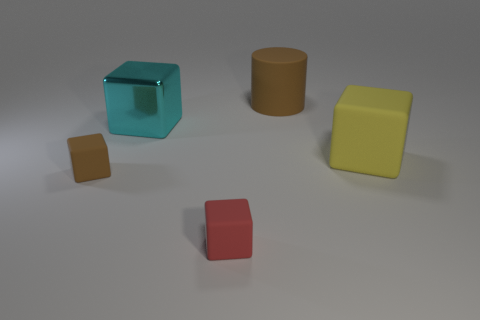Subtract all brown blocks. How many blocks are left? 3 Subtract 1 cylinders. How many cylinders are left? 0 Subtract all cubes. How many objects are left? 1 Subtract all brown cylinders. How many brown cubes are left? 1 Subtract all small red things. Subtract all red blocks. How many objects are left? 3 Add 1 tiny brown blocks. How many tiny brown blocks are left? 2 Add 4 tiny blue objects. How many tiny blue objects exist? 4 Add 4 tiny red objects. How many objects exist? 9 Subtract all cyan blocks. How many blocks are left? 3 Subtract 1 yellow blocks. How many objects are left? 4 